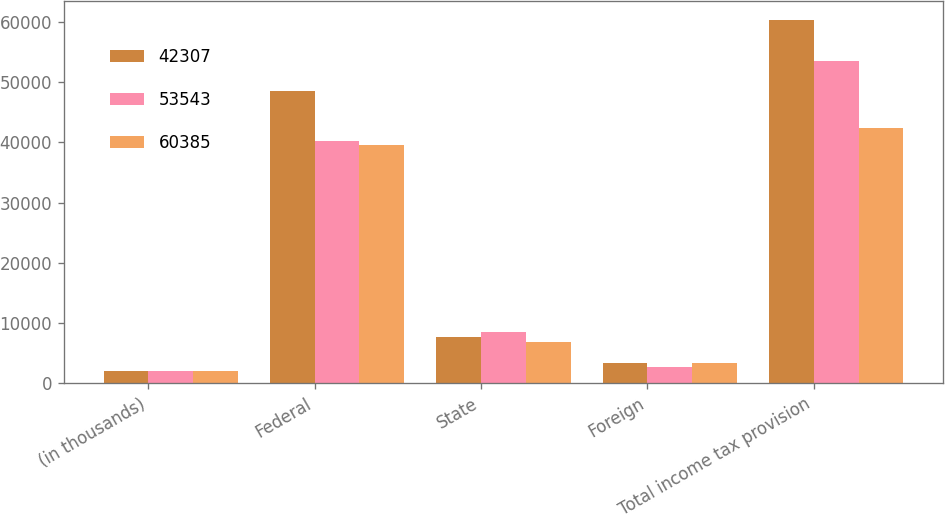<chart> <loc_0><loc_0><loc_500><loc_500><stacked_bar_chart><ecel><fcel>(in thousands)<fcel>Federal<fcel>State<fcel>Foreign<fcel>Total income tax provision<nl><fcel>42307<fcel>2011<fcel>48505<fcel>7723<fcel>3373<fcel>60385<nl><fcel>53543<fcel>2010<fcel>40250<fcel>8494<fcel>2724<fcel>53543<nl><fcel>60385<fcel>2009<fcel>39636<fcel>6802<fcel>3324<fcel>42307<nl></chart> 